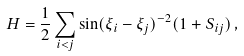Convert formula to latex. <formula><loc_0><loc_0><loc_500><loc_500>H = \frac { 1 } { 2 } \sum _ { i < j } \sin ( \xi _ { i } - \xi _ { j } ) ^ { - 2 } ( 1 + S _ { i j } ) \, ,</formula> 